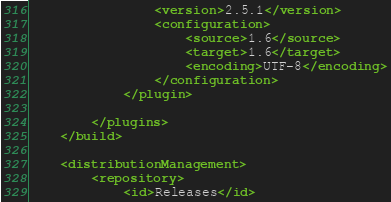Convert code to text. <code><loc_0><loc_0><loc_500><loc_500><_XML_>				<version>2.5.1</version>
				<configuration>
					<source>1.6</source>
					<target>1.6</target>
					<encoding>UTF-8</encoding>
				</configuration>
			</plugin>

		</plugins>
	</build>

	<distributionManagement>
		<repository>
			<id>Releases</id></code> 